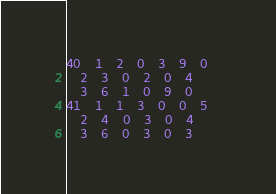Convert code to text. <code><loc_0><loc_0><loc_500><loc_500><_ObjectiveC_>40	1	2	0	3	9	0	
	2	3	0	2	0	4	
	3	6	1	0	9	0	
41	1	1	3	0	0	5	
	2	4	0	3	0	4	
	3	6	0	3	0	3	</code> 